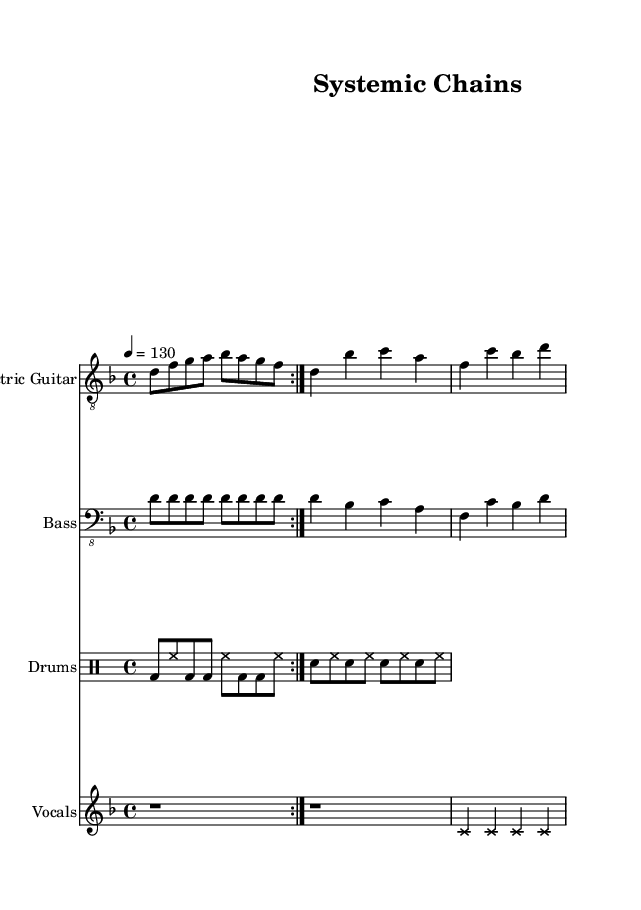What is the key signature of this music? The key signature is D minor, which has one flat (B flat). This can be determined by examining the initial part of the score where the key indication is given.
Answer: D minor What is the time signature of this music? The time signature is 4/4, meaning there are four beats per measure, which can be observed at the beginning of the piece and is consistent throughout.
Answer: 4/4 What is the tempo marking for the piece? The tempo marking indicates a speed of quarter note equals 130 beats per minute, which is explicitly stated in the tempo section of the score.
Answer: 130 How many measures are in the chorus section? The chorus has two measures, which can be counted starting from the simplified chorus progression section that contains the chord changes.
Answer: 2 What type of drum pattern is primarily used? The main drum pattern consists of bass and snare hits with hi-hat, forming a groove characteristic of metal music. This can be observed in the drumming part of the score.
Answer: Groove What is the vocal style indicated in the score? The vocal style includes a placeholder melody with cross note heads, indicating a heavy or aggressive vocal style typical in metal genres. This notation style suggests a rough delivery.
Answer: Aggressive What message does the title "Systemic Chains" suggest regarding the song's theme? The title suggests a commentary on societal or systemic issues, which aligns with the political themes common in groove metal. This can be inferred from the title's wording.
Answer: Political commentary 